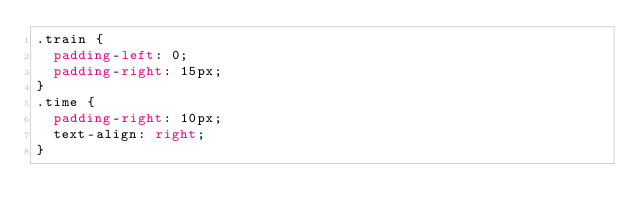<code> <loc_0><loc_0><loc_500><loc_500><_CSS_>.train {
  padding-left: 0;
  padding-right: 15px;
}
.time {
	padding-right: 10px;
	text-align: right;
}</code> 